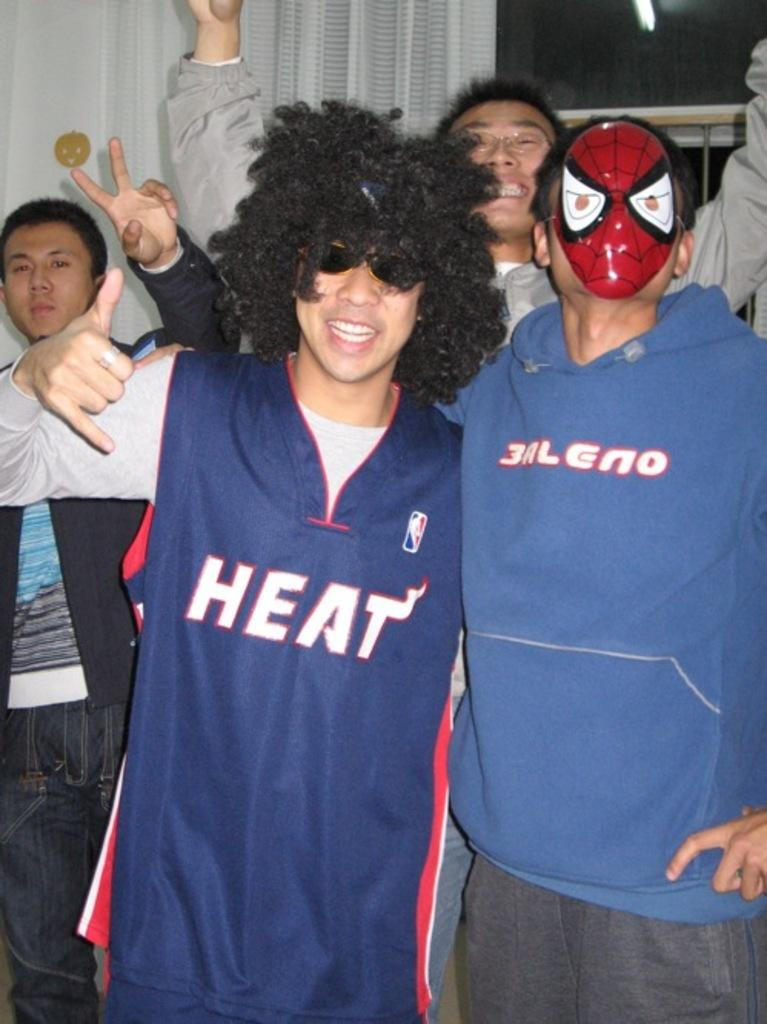Provide a one-sentence caption for the provided image. A man in a Heat jersey poses with friends for a photo. 